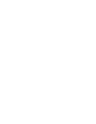<code> <loc_0><loc_0><loc_500><loc_500><_Ruby_>
 
 </code> 